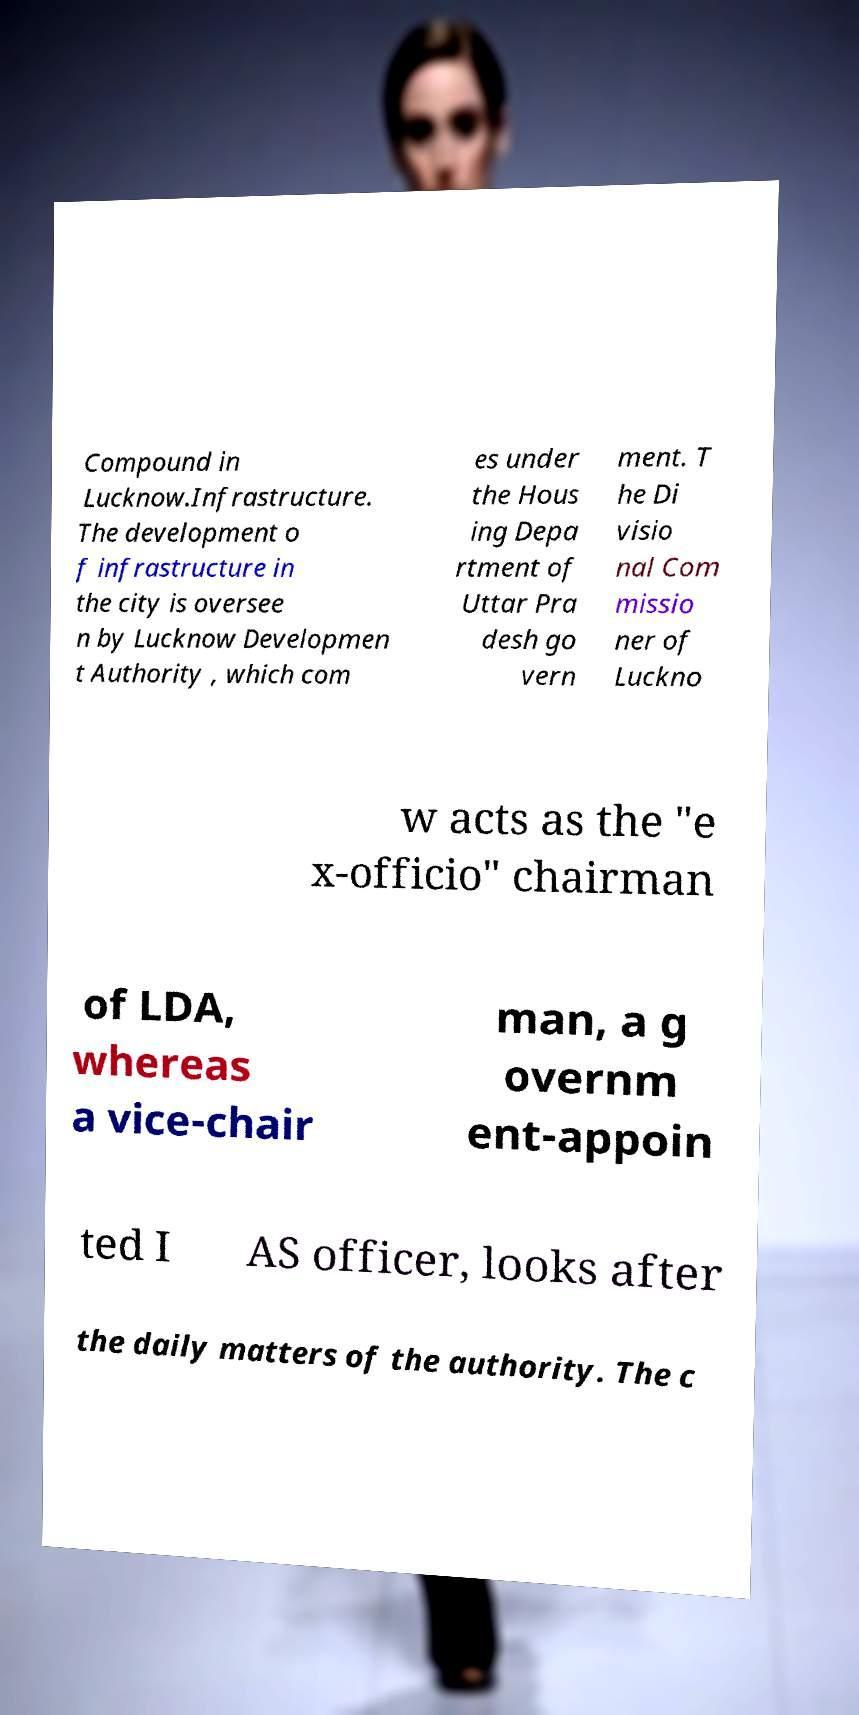Can you read and provide the text displayed in the image?This photo seems to have some interesting text. Can you extract and type it out for me? Compound in Lucknow.Infrastructure. The development o f infrastructure in the city is oversee n by Lucknow Developmen t Authority , which com es under the Hous ing Depa rtment of Uttar Pra desh go vern ment. T he Di visio nal Com missio ner of Luckno w acts as the "e x-officio" chairman of LDA, whereas a vice-chair man, a g overnm ent-appoin ted I AS officer, looks after the daily matters of the authority. The c 